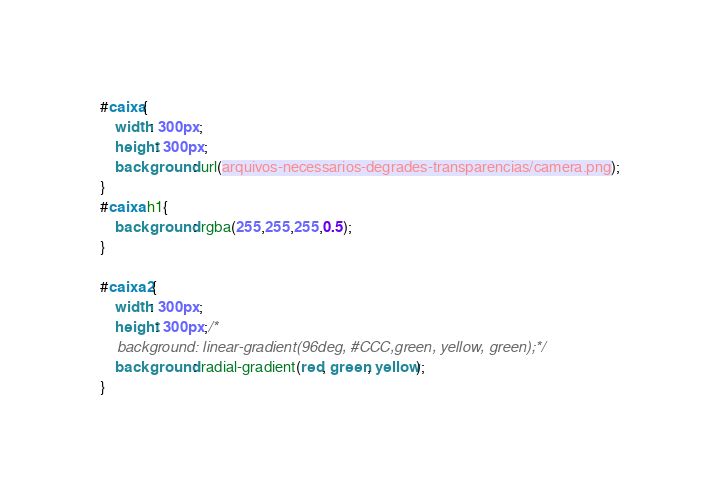<code> <loc_0><loc_0><loc_500><loc_500><_CSS_>#caixa{
    width: 300px;
    height: 300px;
    background: url(arquivos-necessarios-degrades-transparencias/camera.png);
}
#caixa h1{
    background: rgba(255,255,255,0.5);
}

#caixa2{
    width: 300px;
    height: 300px;/*
    background: linear-gradient(96deg, #CCC,green, yellow, green);*/
    background: radial-gradient(red, green, yellow);
}</code> 